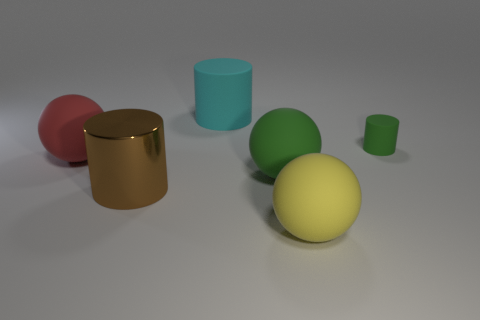Are there any other things that have the same material as the large brown object?
Give a very brief answer. No. Does the red sphere that is left of the small thing have the same material as the big cylinder that is left of the cyan cylinder?
Make the answer very short. No. What color is the large thing that is behind the green matte thing behind the green rubber sphere?
Offer a terse response. Cyan. What size is the red sphere that is made of the same material as the large yellow thing?
Your answer should be very brief. Large. How many big cyan objects are the same shape as the big yellow thing?
Offer a terse response. 0. How many things are big rubber objects in front of the red object or big cylinders right of the shiny thing?
Offer a very short reply. 3. How many rubber balls are in front of the green thing in front of the big red sphere?
Give a very brief answer. 1. Is the shape of the big object in front of the metal cylinder the same as the green rubber thing in front of the red sphere?
Your response must be concise. Yes. There is a large rubber object that is the same color as the tiny thing; what shape is it?
Give a very brief answer. Sphere. Are there any small brown things made of the same material as the small green thing?
Provide a short and direct response. No. 